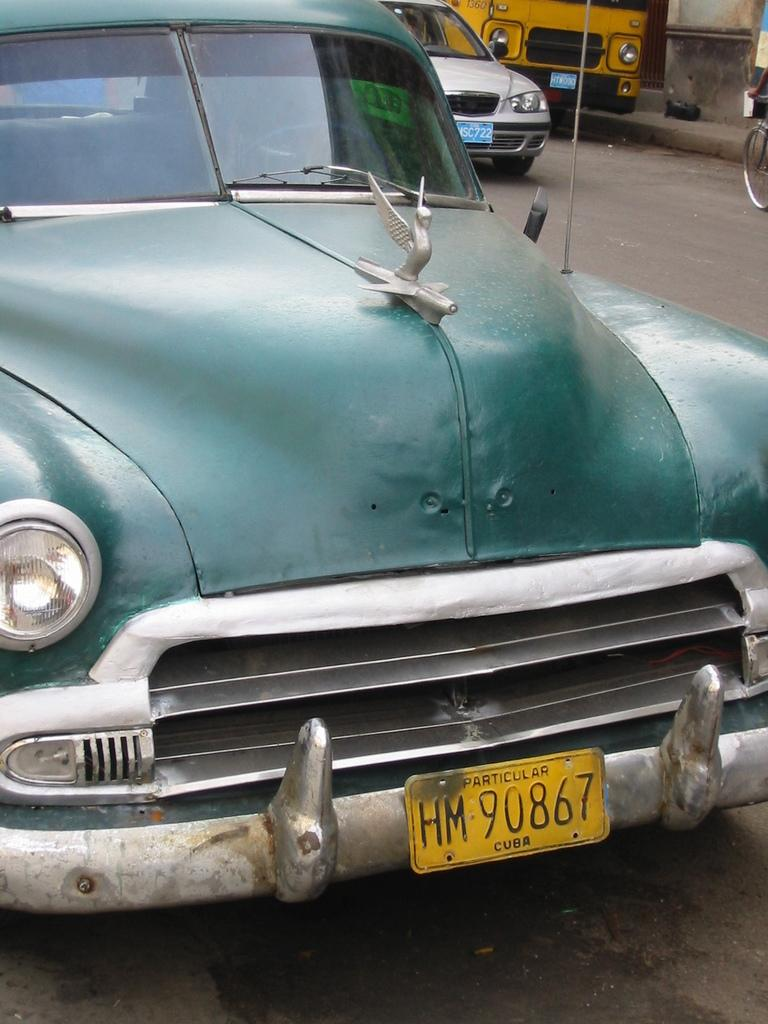Provide a one-sentence caption for the provided image. Street in Cuba with a green car in focus. 